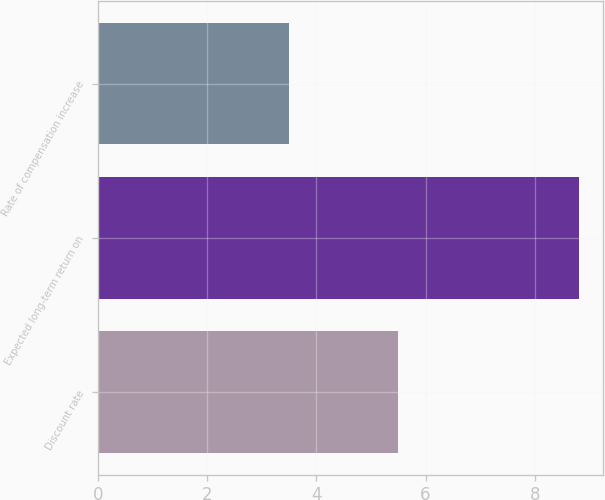Convert chart to OTSL. <chart><loc_0><loc_0><loc_500><loc_500><bar_chart><fcel>Discount rate<fcel>Expected long-term return on<fcel>Rate of compensation increase<nl><fcel>5.5<fcel>8.8<fcel>3.5<nl></chart> 